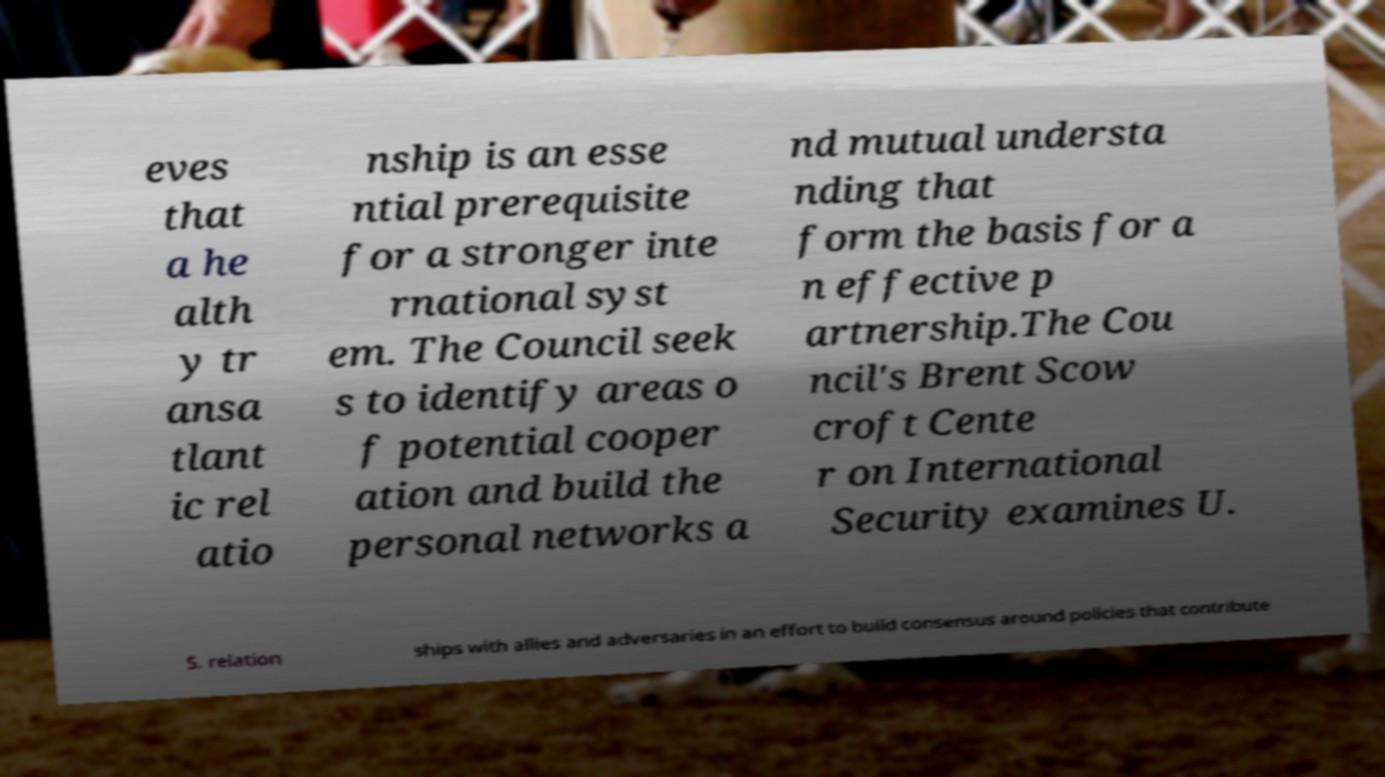I need the written content from this picture converted into text. Can you do that? eves that a he alth y tr ansa tlant ic rel atio nship is an esse ntial prerequisite for a stronger inte rnational syst em. The Council seek s to identify areas o f potential cooper ation and build the personal networks a nd mutual understa nding that form the basis for a n effective p artnership.The Cou ncil's Brent Scow croft Cente r on International Security examines U. S. relation ships with allies and adversaries in an effort to build consensus around policies that contribute 